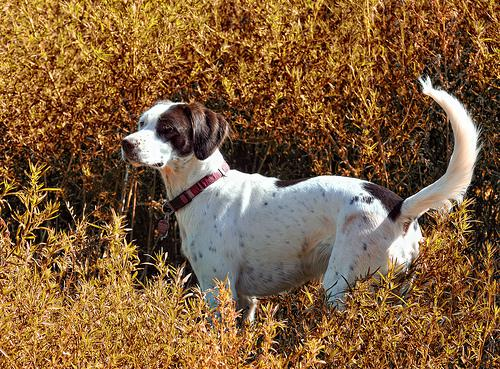Question: who has a tail?
Choices:
A. A cat.
B. A bird.
C. An anteater.
D. A dog.
Answer with the letter. Answer: D Question: where is a collar?
Choices:
A. Around a cat's neck.
B. Around a person's neck.
C. Around the fence post.
D. Around a dog's neck.
Answer with the letter. Answer: D Question: where was the photo taken?
Choices:
A. Near cat.
B. Near puppy.
C. Near catoye.
D. Near dog.
Answer with the letter. Answer: D Question: what is mostly white?
Choices:
A. The dog.
B. The cat.
C. The bird.
D. The llama.
Answer with the letter. Answer: A Question: what is red?
Choices:
A. A shirt.
B. A collar.
C. A skirt.
D. Pants.
Answer with the letter. Answer: B Question: when was the picture taken?
Choices:
A. Evening.
B. Nighttime.
C. Daytime.
D. Sunset.
Answer with the letter. Answer: C 